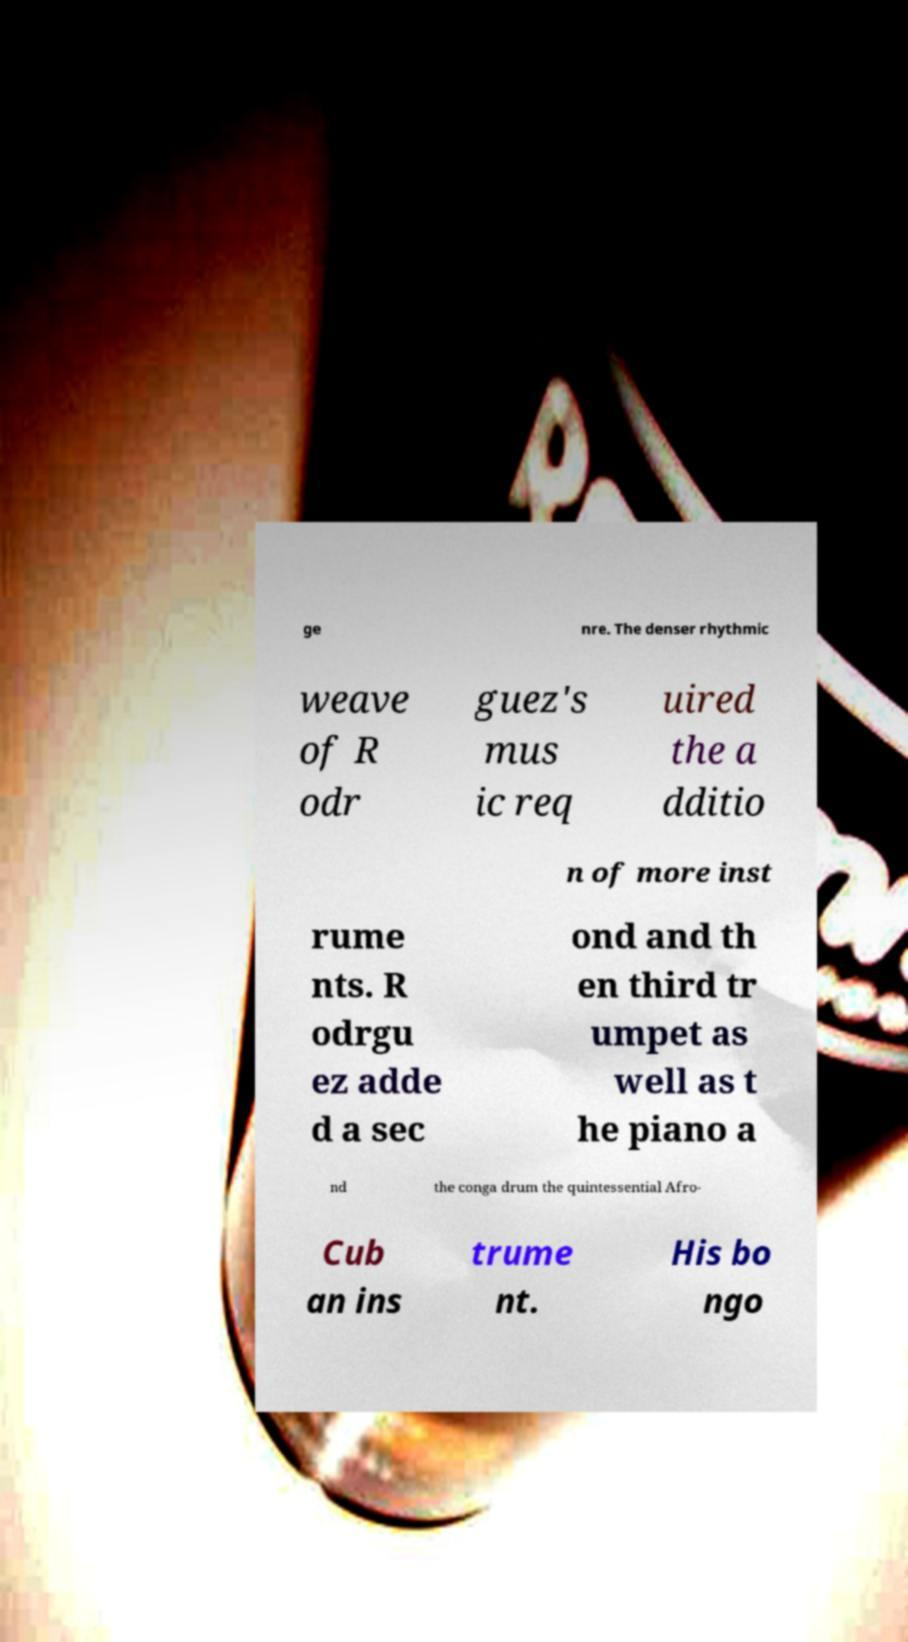There's text embedded in this image that I need extracted. Can you transcribe it verbatim? ge nre. The denser rhythmic weave of R odr guez's mus ic req uired the a dditio n of more inst rume nts. R odrgu ez adde d a sec ond and th en third tr umpet as well as t he piano a nd the conga drum the quintessential Afro- Cub an ins trume nt. His bo ngo 